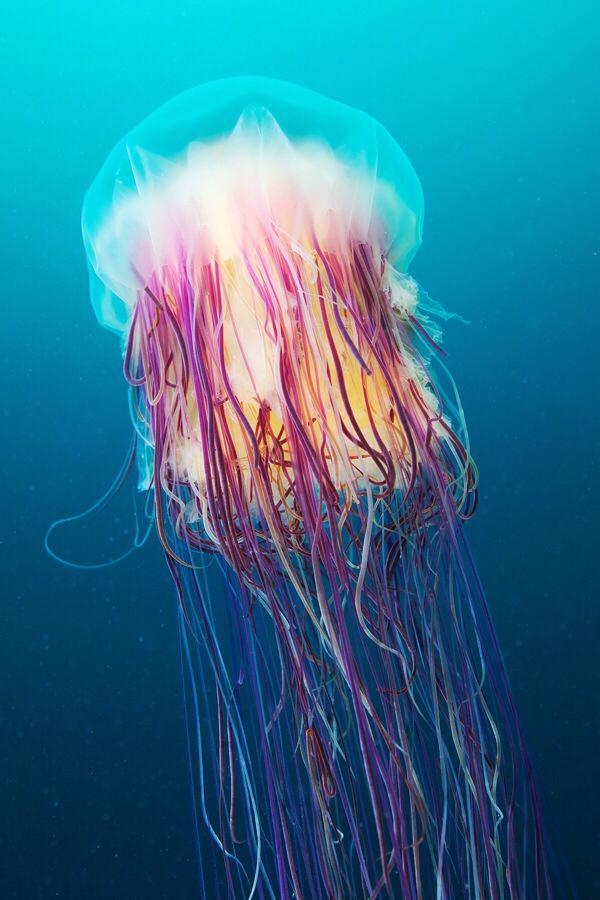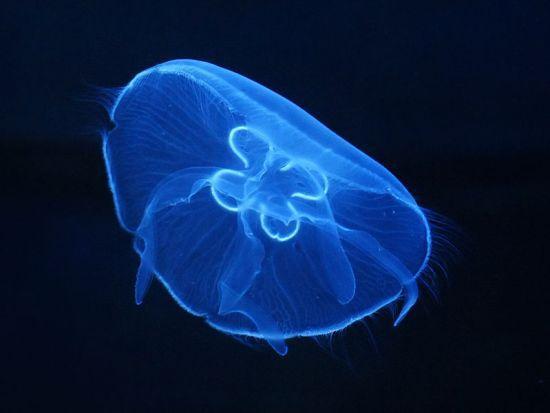The first image is the image on the left, the second image is the image on the right. Considering the images on both sides, is "At least one jellyfish has a striped top." valid? Answer yes or no. No. The first image is the image on the left, the second image is the image on the right. For the images displayed, is the sentence "the body of the jellyfish has dark stripes" factually correct? Answer yes or no. No. 